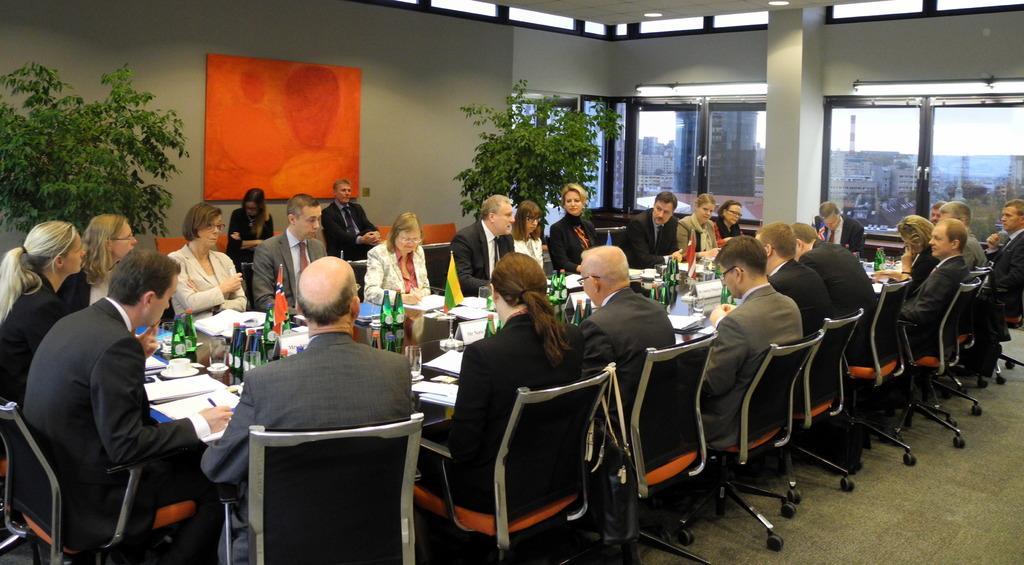Could you give a brief overview of what you see in this image? In this picture we can see a group of people sitting on chairs and in front of them on table we have bottles, flags, papers, cup, saucer, glasses and in the background we can see wall, frame, windows, pillar, trees. 